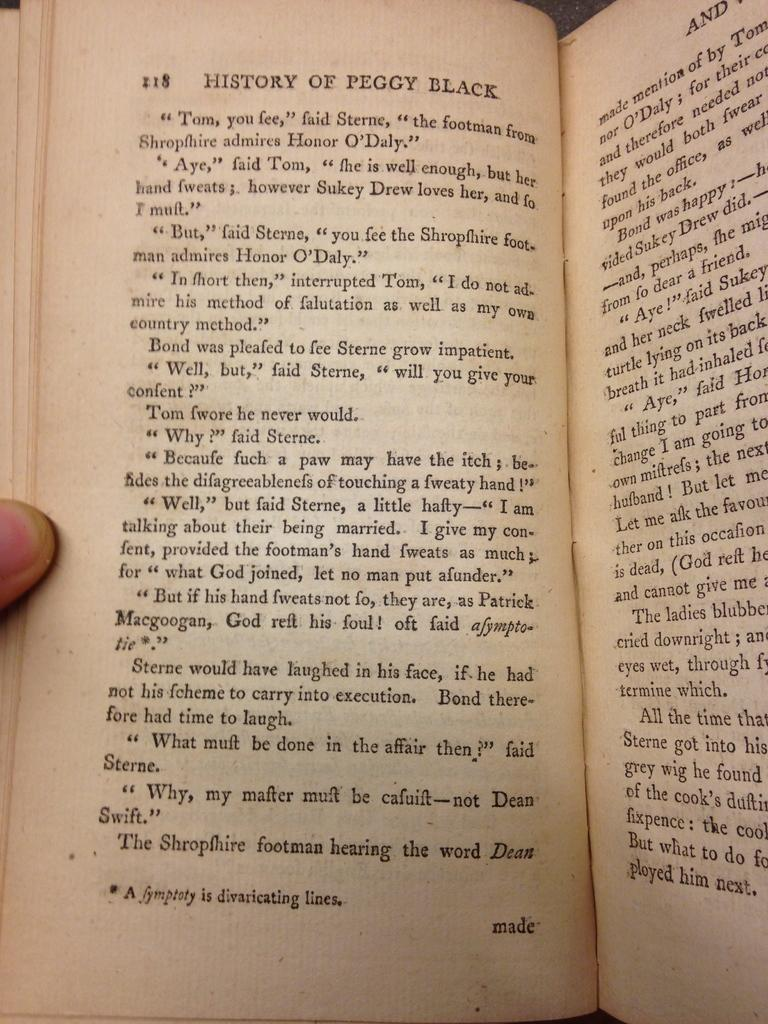Provide a one-sentence caption for the provided image. A book called History of Peggy Black opened to page 118. 